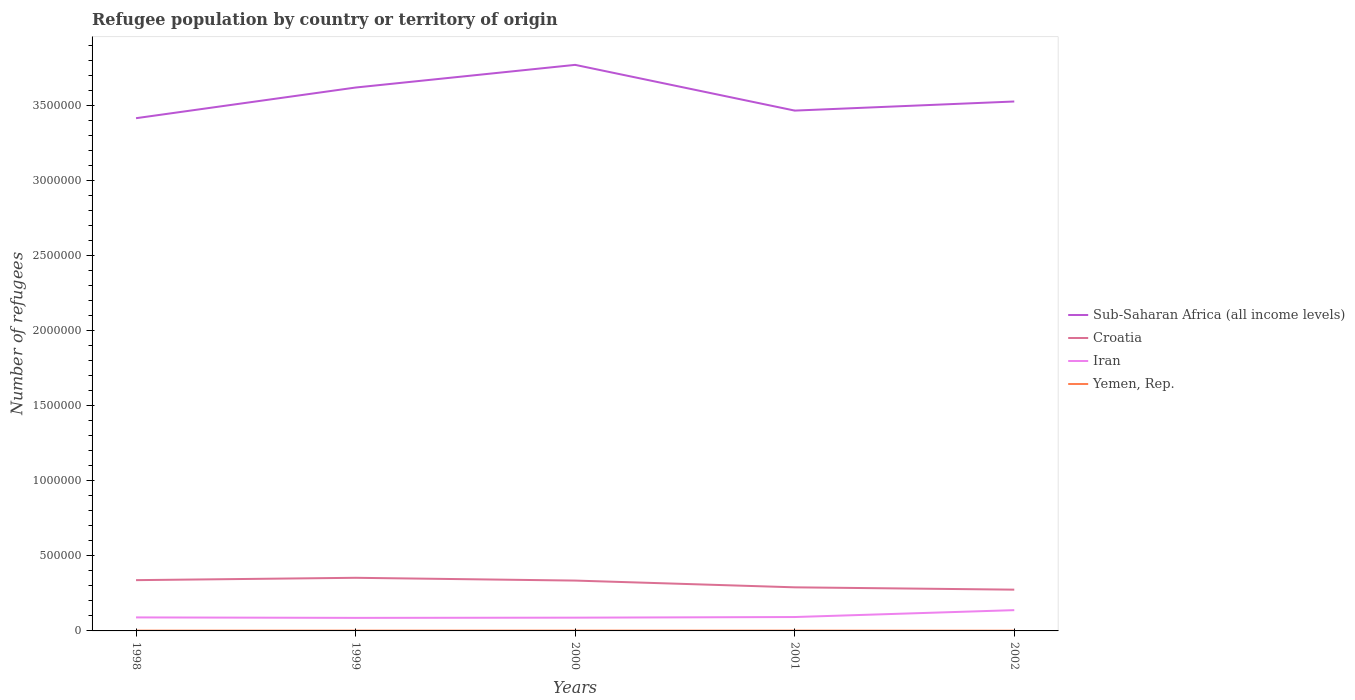Does the line corresponding to Sub-Saharan Africa (all income levels) intersect with the line corresponding to Yemen, Rep.?
Give a very brief answer. No. Is the number of lines equal to the number of legend labels?
Give a very brief answer. Yes. Across all years, what is the maximum number of refugees in Iran?
Provide a short and direct response. 8.69e+04. In which year was the number of refugees in Croatia maximum?
Keep it short and to the point. 2002. What is the total number of refugees in Iran in the graph?
Ensure brevity in your answer.  1701. What is the difference between the highest and the second highest number of refugees in Sub-Saharan Africa (all income levels)?
Ensure brevity in your answer.  3.55e+05. How many years are there in the graph?
Offer a terse response. 5. Does the graph contain any zero values?
Ensure brevity in your answer.  No. Does the graph contain grids?
Your answer should be compact. No. Where does the legend appear in the graph?
Your answer should be compact. Center right. How many legend labels are there?
Provide a short and direct response. 4. How are the legend labels stacked?
Keep it short and to the point. Vertical. What is the title of the graph?
Your answer should be very brief. Refugee population by country or territory of origin. Does "Thailand" appear as one of the legend labels in the graph?
Provide a succinct answer. No. What is the label or title of the Y-axis?
Your answer should be very brief. Number of refugees. What is the Number of refugees of Sub-Saharan Africa (all income levels) in 1998?
Offer a very short reply. 3.41e+06. What is the Number of refugees of Croatia in 1998?
Your answer should be compact. 3.38e+05. What is the Number of refugees of Iran in 1998?
Offer a terse response. 9.00e+04. What is the Number of refugees of Yemen, Rep. in 1998?
Make the answer very short. 1935. What is the Number of refugees in Sub-Saharan Africa (all income levels) in 1999?
Provide a succinct answer. 3.62e+06. What is the Number of refugees of Croatia in 1999?
Give a very brief answer. 3.54e+05. What is the Number of refugees of Iran in 1999?
Make the answer very short. 8.69e+04. What is the Number of refugees in Yemen, Rep. in 1999?
Your answer should be very brief. 2022. What is the Number of refugees in Sub-Saharan Africa (all income levels) in 2000?
Provide a short and direct response. 3.77e+06. What is the Number of refugees in Croatia in 2000?
Provide a short and direct response. 3.35e+05. What is the Number of refugees in Iran in 2000?
Your answer should be compact. 8.83e+04. What is the Number of refugees of Yemen, Rep. in 2000?
Offer a terse response. 2113. What is the Number of refugees in Sub-Saharan Africa (all income levels) in 2001?
Your answer should be compact. 3.46e+06. What is the Number of refugees in Croatia in 2001?
Offer a terse response. 2.90e+05. What is the Number of refugees of Iran in 2001?
Keep it short and to the point. 9.25e+04. What is the Number of refugees of Yemen, Rep. in 2001?
Provide a short and direct response. 1985. What is the Number of refugees in Sub-Saharan Africa (all income levels) in 2002?
Your response must be concise. 3.53e+06. What is the Number of refugees in Croatia in 2002?
Your answer should be compact. 2.75e+05. What is the Number of refugees of Iran in 2002?
Offer a terse response. 1.38e+05. What is the Number of refugees in Yemen, Rep. in 2002?
Give a very brief answer. 1600. Across all years, what is the maximum Number of refugees in Sub-Saharan Africa (all income levels)?
Your answer should be compact. 3.77e+06. Across all years, what is the maximum Number of refugees of Croatia?
Your answer should be very brief. 3.54e+05. Across all years, what is the maximum Number of refugees in Iran?
Give a very brief answer. 1.38e+05. Across all years, what is the maximum Number of refugees of Yemen, Rep.?
Offer a terse response. 2113. Across all years, what is the minimum Number of refugees of Sub-Saharan Africa (all income levels)?
Give a very brief answer. 3.41e+06. Across all years, what is the minimum Number of refugees of Croatia?
Your answer should be very brief. 2.75e+05. Across all years, what is the minimum Number of refugees of Iran?
Give a very brief answer. 8.69e+04. Across all years, what is the minimum Number of refugees of Yemen, Rep.?
Make the answer very short. 1600. What is the total Number of refugees of Sub-Saharan Africa (all income levels) in the graph?
Give a very brief answer. 1.78e+07. What is the total Number of refugees of Croatia in the graph?
Ensure brevity in your answer.  1.59e+06. What is the total Number of refugees of Iran in the graph?
Your response must be concise. 4.96e+05. What is the total Number of refugees in Yemen, Rep. in the graph?
Your answer should be very brief. 9655. What is the difference between the Number of refugees of Sub-Saharan Africa (all income levels) in 1998 and that in 1999?
Provide a succinct answer. -2.04e+05. What is the difference between the Number of refugees in Croatia in 1998 and that in 1999?
Keep it short and to the point. -1.56e+04. What is the difference between the Number of refugees of Iran in 1998 and that in 1999?
Your answer should be very brief. 3124. What is the difference between the Number of refugees of Yemen, Rep. in 1998 and that in 1999?
Give a very brief answer. -87. What is the difference between the Number of refugees of Sub-Saharan Africa (all income levels) in 1998 and that in 2000?
Offer a very short reply. -3.55e+05. What is the difference between the Number of refugees of Croatia in 1998 and that in 2000?
Ensure brevity in your answer.  2890. What is the difference between the Number of refugees of Iran in 1998 and that in 2000?
Provide a short and direct response. 1701. What is the difference between the Number of refugees in Yemen, Rep. in 1998 and that in 2000?
Keep it short and to the point. -178. What is the difference between the Number of refugees in Sub-Saharan Africa (all income levels) in 1998 and that in 2001?
Your response must be concise. -5.06e+04. What is the difference between the Number of refugees of Croatia in 1998 and that in 2001?
Make the answer very short. 4.78e+04. What is the difference between the Number of refugees of Iran in 1998 and that in 2001?
Your answer should be very brief. -2512. What is the difference between the Number of refugees in Yemen, Rep. in 1998 and that in 2001?
Your answer should be very brief. -50. What is the difference between the Number of refugees of Sub-Saharan Africa (all income levels) in 1998 and that in 2002?
Your response must be concise. -1.11e+05. What is the difference between the Number of refugees in Croatia in 1998 and that in 2002?
Your answer should be compact. 6.33e+04. What is the difference between the Number of refugees of Iran in 1998 and that in 2002?
Offer a terse response. -4.84e+04. What is the difference between the Number of refugees in Yemen, Rep. in 1998 and that in 2002?
Ensure brevity in your answer.  335. What is the difference between the Number of refugees of Sub-Saharan Africa (all income levels) in 1999 and that in 2000?
Your answer should be compact. -1.51e+05. What is the difference between the Number of refugees in Croatia in 1999 and that in 2000?
Offer a very short reply. 1.85e+04. What is the difference between the Number of refugees of Iran in 1999 and that in 2000?
Offer a terse response. -1423. What is the difference between the Number of refugees in Yemen, Rep. in 1999 and that in 2000?
Provide a short and direct response. -91. What is the difference between the Number of refugees in Sub-Saharan Africa (all income levels) in 1999 and that in 2001?
Offer a terse response. 1.54e+05. What is the difference between the Number of refugees in Croatia in 1999 and that in 2001?
Ensure brevity in your answer.  6.34e+04. What is the difference between the Number of refugees of Iran in 1999 and that in 2001?
Ensure brevity in your answer.  -5636. What is the difference between the Number of refugees of Yemen, Rep. in 1999 and that in 2001?
Ensure brevity in your answer.  37. What is the difference between the Number of refugees in Sub-Saharan Africa (all income levels) in 1999 and that in 2002?
Keep it short and to the point. 9.30e+04. What is the difference between the Number of refugees in Croatia in 1999 and that in 2002?
Your answer should be compact. 7.89e+04. What is the difference between the Number of refugees of Iran in 1999 and that in 2002?
Offer a terse response. -5.15e+04. What is the difference between the Number of refugees of Yemen, Rep. in 1999 and that in 2002?
Ensure brevity in your answer.  422. What is the difference between the Number of refugees of Sub-Saharan Africa (all income levels) in 2000 and that in 2001?
Offer a terse response. 3.04e+05. What is the difference between the Number of refugees of Croatia in 2000 and that in 2001?
Your response must be concise. 4.49e+04. What is the difference between the Number of refugees of Iran in 2000 and that in 2001?
Keep it short and to the point. -4213. What is the difference between the Number of refugees in Yemen, Rep. in 2000 and that in 2001?
Provide a short and direct response. 128. What is the difference between the Number of refugees of Sub-Saharan Africa (all income levels) in 2000 and that in 2002?
Keep it short and to the point. 2.44e+05. What is the difference between the Number of refugees of Croatia in 2000 and that in 2002?
Provide a short and direct response. 6.04e+04. What is the difference between the Number of refugees in Iran in 2000 and that in 2002?
Your answer should be very brief. -5.01e+04. What is the difference between the Number of refugees in Yemen, Rep. in 2000 and that in 2002?
Offer a terse response. 513. What is the difference between the Number of refugees in Sub-Saharan Africa (all income levels) in 2001 and that in 2002?
Provide a short and direct response. -6.06e+04. What is the difference between the Number of refugees in Croatia in 2001 and that in 2002?
Your response must be concise. 1.55e+04. What is the difference between the Number of refugees in Iran in 2001 and that in 2002?
Make the answer very short. -4.59e+04. What is the difference between the Number of refugees of Yemen, Rep. in 2001 and that in 2002?
Make the answer very short. 385. What is the difference between the Number of refugees in Sub-Saharan Africa (all income levels) in 1998 and the Number of refugees in Croatia in 1999?
Offer a terse response. 3.06e+06. What is the difference between the Number of refugees in Sub-Saharan Africa (all income levels) in 1998 and the Number of refugees in Iran in 1999?
Offer a very short reply. 3.33e+06. What is the difference between the Number of refugees of Sub-Saharan Africa (all income levels) in 1998 and the Number of refugees of Yemen, Rep. in 1999?
Make the answer very short. 3.41e+06. What is the difference between the Number of refugees in Croatia in 1998 and the Number of refugees in Iran in 1999?
Give a very brief answer. 2.51e+05. What is the difference between the Number of refugees in Croatia in 1998 and the Number of refugees in Yemen, Rep. in 1999?
Your response must be concise. 3.36e+05. What is the difference between the Number of refugees in Iran in 1998 and the Number of refugees in Yemen, Rep. in 1999?
Ensure brevity in your answer.  8.80e+04. What is the difference between the Number of refugees in Sub-Saharan Africa (all income levels) in 1998 and the Number of refugees in Croatia in 2000?
Provide a short and direct response. 3.08e+06. What is the difference between the Number of refugees in Sub-Saharan Africa (all income levels) in 1998 and the Number of refugees in Iran in 2000?
Make the answer very short. 3.33e+06. What is the difference between the Number of refugees in Sub-Saharan Africa (all income levels) in 1998 and the Number of refugees in Yemen, Rep. in 2000?
Make the answer very short. 3.41e+06. What is the difference between the Number of refugees of Croatia in 1998 and the Number of refugees of Iran in 2000?
Offer a terse response. 2.50e+05. What is the difference between the Number of refugees of Croatia in 1998 and the Number of refugees of Yemen, Rep. in 2000?
Offer a terse response. 3.36e+05. What is the difference between the Number of refugees in Iran in 1998 and the Number of refugees in Yemen, Rep. in 2000?
Make the answer very short. 8.79e+04. What is the difference between the Number of refugees in Sub-Saharan Africa (all income levels) in 1998 and the Number of refugees in Croatia in 2001?
Your answer should be very brief. 3.12e+06. What is the difference between the Number of refugees in Sub-Saharan Africa (all income levels) in 1998 and the Number of refugees in Iran in 2001?
Provide a short and direct response. 3.32e+06. What is the difference between the Number of refugees of Sub-Saharan Africa (all income levels) in 1998 and the Number of refugees of Yemen, Rep. in 2001?
Offer a very short reply. 3.41e+06. What is the difference between the Number of refugees in Croatia in 1998 and the Number of refugees in Iran in 2001?
Offer a terse response. 2.46e+05. What is the difference between the Number of refugees of Croatia in 1998 and the Number of refugees of Yemen, Rep. in 2001?
Your answer should be compact. 3.36e+05. What is the difference between the Number of refugees in Iran in 1998 and the Number of refugees in Yemen, Rep. in 2001?
Your answer should be very brief. 8.80e+04. What is the difference between the Number of refugees in Sub-Saharan Africa (all income levels) in 1998 and the Number of refugees in Croatia in 2002?
Offer a very short reply. 3.14e+06. What is the difference between the Number of refugees in Sub-Saharan Africa (all income levels) in 1998 and the Number of refugees in Iran in 2002?
Your answer should be very brief. 3.28e+06. What is the difference between the Number of refugees in Sub-Saharan Africa (all income levels) in 1998 and the Number of refugees in Yemen, Rep. in 2002?
Offer a terse response. 3.41e+06. What is the difference between the Number of refugees of Croatia in 1998 and the Number of refugees of Iran in 2002?
Provide a short and direct response. 2.00e+05. What is the difference between the Number of refugees of Croatia in 1998 and the Number of refugees of Yemen, Rep. in 2002?
Make the answer very short. 3.36e+05. What is the difference between the Number of refugees of Iran in 1998 and the Number of refugees of Yemen, Rep. in 2002?
Give a very brief answer. 8.84e+04. What is the difference between the Number of refugees of Sub-Saharan Africa (all income levels) in 1999 and the Number of refugees of Croatia in 2000?
Make the answer very short. 3.28e+06. What is the difference between the Number of refugees of Sub-Saharan Africa (all income levels) in 1999 and the Number of refugees of Iran in 2000?
Provide a succinct answer. 3.53e+06. What is the difference between the Number of refugees in Sub-Saharan Africa (all income levels) in 1999 and the Number of refugees in Yemen, Rep. in 2000?
Your answer should be very brief. 3.62e+06. What is the difference between the Number of refugees in Croatia in 1999 and the Number of refugees in Iran in 2000?
Provide a short and direct response. 2.65e+05. What is the difference between the Number of refugees of Croatia in 1999 and the Number of refugees of Yemen, Rep. in 2000?
Your answer should be very brief. 3.52e+05. What is the difference between the Number of refugees in Iran in 1999 and the Number of refugees in Yemen, Rep. in 2000?
Offer a very short reply. 8.47e+04. What is the difference between the Number of refugees in Sub-Saharan Africa (all income levels) in 1999 and the Number of refugees in Croatia in 2001?
Offer a very short reply. 3.33e+06. What is the difference between the Number of refugees in Sub-Saharan Africa (all income levels) in 1999 and the Number of refugees in Iran in 2001?
Your response must be concise. 3.53e+06. What is the difference between the Number of refugees in Sub-Saharan Africa (all income levels) in 1999 and the Number of refugees in Yemen, Rep. in 2001?
Make the answer very short. 3.62e+06. What is the difference between the Number of refugees of Croatia in 1999 and the Number of refugees of Iran in 2001?
Your answer should be very brief. 2.61e+05. What is the difference between the Number of refugees of Croatia in 1999 and the Number of refugees of Yemen, Rep. in 2001?
Your response must be concise. 3.52e+05. What is the difference between the Number of refugees in Iran in 1999 and the Number of refugees in Yemen, Rep. in 2001?
Ensure brevity in your answer.  8.49e+04. What is the difference between the Number of refugees of Sub-Saharan Africa (all income levels) in 1999 and the Number of refugees of Croatia in 2002?
Offer a terse response. 3.34e+06. What is the difference between the Number of refugees of Sub-Saharan Africa (all income levels) in 1999 and the Number of refugees of Iran in 2002?
Make the answer very short. 3.48e+06. What is the difference between the Number of refugees of Sub-Saharan Africa (all income levels) in 1999 and the Number of refugees of Yemen, Rep. in 2002?
Your response must be concise. 3.62e+06. What is the difference between the Number of refugees in Croatia in 1999 and the Number of refugees in Iran in 2002?
Provide a succinct answer. 2.15e+05. What is the difference between the Number of refugees of Croatia in 1999 and the Number of refugees of Yemen, Rep. in 2002?
Your response must be concise. 3.52e+05. What is the difference between the Number of refugees of Iran in 1999 and the Number of refugees of Yemen, Rep. in 2002?
Provide a succinct answer. 8.53e+04. What is the difference between the Number of refugees in Sub-Saharan Africa (all income levels) in 2000 and the Number of refugees in Croatia in 2001?
Your response must be concise. 3.48e+06. What is the difference between the Number of refugees in Sub-Saharan Africa (all income levels) in 2000 and the Number of refugees in Iran in 2001?
Offer a terse response. 3.68e+06. What is the difference between the Number of refugees of Sub-Saharan Africa (all income levels) in 2000 and the Number of refugees of Yemen, Rep. in 2001?
Offer a terse response. 3.77e+06. What is the difference between the Number of refugees in Croatia in 2000 and the Number of refugees in Iran in 2001?
Your answer should be very brief. 2.43e+05. What is the difference between the Number of refugees in Croatia in 2000 and the Number of refugees in Yemen, Rep. in 2001?
Provide a succinct answer. 3.33e+05. What is the difference between the Number of refugees in Iran in 2000 and the Number of refugees in Yemen, Rep. in 2001?
Your response must be concise. 8.63e+04. What is the difference between the Number of refugees in Sub-Saharan Africa (all income levels) in 2000 and the Number of refugees in Croatia in 2002?
Your answer should be very brief. 3.49e+06. What is the difference between the Number of refugees in Sub-Saharan Africa (all income levels) in 2000 and the Number of refugees in Iran in 2002?
Offer a terse response. 3.63e+06. What is the difference between the Number of refugees of Sub-Saharan Africa (all income levels) in 2000 and the Number of refugees of Yemen, Rep. in 2002?
Offer a very short reply. 3.77e+06. What is the difference between the Number of refugees in Croatia in 2000 and the Number of refugees in Iran in 2002?
Your answer should be compact. 1.97e+05. What is the difference between the Number of refugees of Croatia in 2000 and the Number of refugees of Yemen, Rep. in 2002?
Your response must be concise. 3.34e+05. What is the difference between the Number of refugees of Iran in 2000 and the Number of refugees of Yemen, Rep. in 2002?
Make the answer very short. 8.67e+04. What is the difference between the Number of refugees of Sub-Saharan Africa (all income levels) in 2001 and the Number of refugees of Croatia in 2002?
Offer a very short reply. 3.19e+06. What is the difference between the Number of refugees of Sub-Saharan Africa (all income levels) in 2001 and the Number of refugees of Iran in 2002?
Your answer should be compact. 3.33e+06. What is the difference between the Number of refugees of Sub-Saharan Africa (all income levels) in 2001 and the Number of refugees of Yemen, Rep. in 2002?
Provide a succinct answer. 3.46e+06. What is the difference between the Number of refugees in Croatia in 2001 and the Number of refugees in Iran in 2002?
Offer a terse response. 1.52e+05. What is the difference between the Number of refugees of Croatia in 2001 and the Number of refugees of Yemen, Rep. in 2002?
Your response must be concise. 2.89e+05. What is the difference between the Number of refugees of Iran in 2001 and the Number of refugees of Yemen, Rep. in 2002?
Offer a very short reply. 9.09e+04. What is the average Number of refugees in Sub-Saharan Africa (all income levels) per year?
Offer a very short reply. 3.56e+06. What is the average Number of refugees in Croatia per year?
Make the answer very short. 3.18e+05. What is the average Number of refugees of Iran per year?
Your answer should be compact. 9.92e+04. What is the average Number of refugees of Yemen, Rep. per year?
Keep it short and to the point. 1931. In the year 1998, what is the difference between the Number of refugees of Sub-Saharan Africa (all income levels) and Number of refugees of Croatia?
Your response must be concise. 3.08e+06. In the year 1998, what is the difference between the Number of refugees in Sub-Saharan Africa (all income levels) and Number of refugees in Iran?
Your response must be concise. 3.32e+06. In the year 1998, what is the difference between the Number of refugees of Sub-Saharan Africa (all income levels) and Number of refugees of Yemen, Rep.?
Provide a short and direct response. 3.41e+06. In the year 1998, what is the difference between the Number of refugees in Croatia and Number of refugees in Iran?
Ensure brevity in your answer.  2.48e+05. In the year 1998, what is the difference between the Number of refugees in Croatia and Number of refugees in Yemen, Rep.?
Provide a succinct answer. 3.36e+05. In the year 1998, what is the difference between the Number of refugees of Iran and Number of refugees of Yemen, Rep.?
Your response must be concise. 8.80e+04. In the year 1999, what is the difference between the Number of refugees of Sub-Saharan Africa (all income levels) and Number of refugees of Croatia?
Give a very brief answer. 3.26e+06. In the year 1999, what is the difference between the Number of refugees of Sub-Saharan Africa (all income levels) and Number of refugees of Iran?
Offer a terse response. 3.53e+06. In the year 1999, what is the difference between the Number of refugees of Sub-Saharan Africa (all income levels) and Number of refugees of Yemen, Rep.?
Your response must be concise. 3.62e+06. In the year 1999, what is the difference between the Number of refugees in Croatia and Number of refugees in Iran?
Make the answer very short. 2.67e+05. In the year 1999, what is the difference between the Number of refugees of Croatia and Number of refugees of Yemen, Rep.?
Your response must be concise. 3.52e+05. In the year 1999, what is the difference between the Number of refugees of Iran and Number of refugees of Yemen, Rep.?
Offer a very short reply. 8.48e+04. In the year 2000, what is the difference between the Number of refugees in Sub-Saharan Africa (all income levels) and Number of refugees in Croatia?
Offer a terse response. 3.43e+06. In the year 2000, what is the difference between the Number of refugees of Sub-Saharan Africa (all income levels) and Number of refugees of Iran?
Keep it short and to the point. 3.68e+06. In the year 2000, what is the difference between the Number of refugees of Sub-Saharan Africa (all income levels) and Number of refugees of Yemen, Rep.?
Your answer should be very brief. 3.77e+06. In the year 2000, what is the difference between the Number of refugees of Croatia and Number of refugees of Iran?
Make the answer very short. 2.47e+05. In the year 2000, what is the difference between the Number of refugees in Croatia and Number of refugees in Yemen, Rep.?
Make the answer very short. 3.33e+05. In the year 2000, what is the difference between the Number of refugees of Iran and Number of refugees of Yemen, Rep.?
Provide a short and direct response. 8.62e+04. In the year 2001, what is the difference between the Number of refugees in Sub-Saharan Africa (all income levels) and Number of refugees in Croatia?
Give a very brief answer. 3.17e+06. In the year 2001, what is the difference between the Number of refugees of Sub-Saharan Africa (all income levels) and Number of refugees of Iran?
Make the answer very short. 3.37e+06. In the year 2001, what is the difference between the Number of refugees of Sub-Saharan Africa (all income levels) and Number of refugees of Yemen, Rep.?
Offer a terse response. 3.46e+06. In the year 2001, what is the difference between the Number of refugees of Croatia and Number of refugees of Iran?
Your answer should be very brief. 1.98e+05. In the year 2001, what is the difference between the Number of refugees of Croatia and Number of refugees of Yemen, Rep.?
Offer a very short reply. 2.88e+05. In the year 2001, what is the difference between the Number of refugees in Iran and Number of refugees in Yemen, Rep.?
Your answer should be compact. 9.05e+04. In the year 2002, what is the difference between the Number of refugees in Sub-Saharan Africa (all income levels) and Number of refugees in Croatia?
Provide a short and direct response. 3.25e+06. In the year 2002, what is the difference between the Number of refugees in Sub-Saharan Africa (all income levels) and Number of refugees in Iran?
Provide a short and direct response. 3.39e+06. In the year 2002, what is the difference between the Number of refugees in Sub-Saharan Africa (all income levels) and Number of refugees in Yemen, Rep.?
Your answer should be compact. 3.52e+06. In the year 2002, what is the difference between the Number of refugees in Croatia and Number of refugees in Iran?
Your response must be concise. 1.36e+05. In the year 2002, what is the difference between the Number of refugees in Croatia and Number of refugees in Yemen, Rep.?
Ensure brevity in your answer.  2.73e+05. In the year 2002, what is the difference between the Number of refugees in Iran and Number of refugees in Yemen, Rep.?
Provide a short and direct response. 1.37e+05. What is the ratio of the Number of refugees of Sub-Saharan Africa (all income levels) in 1998 to that in 1999?
Offer a terse response. 0.94. What is the ratio of the Number of refugees of Croatia in 1998 to that in 1999?
Ensure brevity in your answer.  0.96. What is the ratio of the Number of refugees in Iran in 1998 to that in 1999?
Your answer should be very brief. 1.04. What is the ratio of the Number of refugees in Sub-Saharan Africa (all income levels) in 1998 to that in 2000?
Offer a terse response. 0.91. What is the ratio of the Number of refugees of Croatia in 1998 to that in 2000?
Provide a succinct answer. 1.01. What is the ratio of the Number of refugees in Iran in 1998 to that in 2000?
Your answer should be compact. 1.02. What is the ratio of the Number of refugees of Yemen, Rep. in 1998 to that in 2000?
Your answer should be very brief. 0.92. What is the ratio of the Number of refugees in Sub-Saharan Africa (all income levels) in 1998 to that in 2001?
Make the answer very short. 0.99. What is the ratio of the Number of refugees of Croatia in 1998 to that in 2001?
Offer a very short reply. 1.16. What is the ratio of the Number of refugees in Iran in 1998 to that in 2001?
Your answer should be very brief. 0.97. What is the ratio of the Number of refugees in Yemen, Rep. in 1998 to that in 2001?
Your answer should be very brief. 0.97. What is the ratio of the Number of refugees of Sub-Saharan Africa (all income levels) in 1998 to that in 2002?
Give a very brief answer. 0.97. What is the ratio of the Number of refugees in Croatia in 1998 to that in 2002?
Keep it short and to the point. 1.23. What is the ratio of the Number of refugees of Iran in 1998 to that in 2002?
Offer a very short reply. 0.65. What is the ratio of the Number of refugees in Yemen, Rep. in 1998 to that in 2002?
Provide a succinct answer. 1.21. What is the ratio of the Number of refugees in Croatia in 1999 to that in 2000?
Offer a terse response. 1.06. What is the ratio of the Number of refugees of Iran in 1999 to that in 2000?
Your response must be concise. 0.98. What is the ratio of the Number of refugees in Yemen, Rep. in 1999 to that in 2000?
Your response must be concise. 0.96. What is the ratio of the Number of refugees in Sub-Saharan Africa (all income levels) in 1999 to that in 2001?
Your response must be concise. 1.04. What is the ratio of the Number of refugees of Croatia in 1999 to that in 2001?
Ensure brevity in your answer.  1.22. What is the ratio of the Number of refugees of Iran in 1999 to that in 2001?
Give a very brief answer. 0.94. What is the ratio of the Number of refugees of Yemen, Rep. in 1999 to that in 2001?
Give a very brief answer. 1.02. What is the ratio of the Number of refugees of Sub-Saharan Africa (all income levels) in 1999 to that in 2002?
Your answer should be very brief. 1.03. What is the ratio of the Number of refugees in Croatia in 1999 to that in 2002?
Make the answer very short. 1.29. What is the ratio of the Number of refugees in Iran in 1999 to that in 2002?
Give a very brief answer. 0.63. What is the ratio of the Number of refugees of Yemen, Rep. in 1999 to that in 2002?
Your answer should be very brief. 1.26. What is the ratio of the Number of refugees of Sub-Saharan Africa (all income levels) in 2000 to that in 2001?
Provide a succinct answer. 1.09. What is the ratio of the Number of refugees of Croatia in 2000 to that in 2001?
Give a very brief answer. 1.15. What is the ratio of the Number of refugees in Iran in 2000 to that in 2001?
Make the answer very short. 0.95. What is the ratio of the Number of refugees of Yemen, Rep. in 2000 to that in 2001?
Offer a terse response. 1.06. What is the ratio of the Number of refugees in Sub-Saharan Africa (all income levels) in 2000 to that in 2002?
Offer a terse response. 1.07. What is the ratio of the Number of refugees of Croatia in 2000 to that in 2002?
Make the answer very short. 1.22. What is the ratio of the Number of refugees in Iran in 2000 to that in 2002?
Your answer should be very brief. 0.64. What is the ratio of the Number of refugees in Yemen, Rep. in 2000 to that in 2002?
Provide a short and direct response. 1.32. What is the ratio of the Number of refugees in Sub-Saharan Africa (all income levels) in 2001 to that in 2002?
Make the answer very short. 0.98. What is the ratio of the Number of refugees of Croatia in 2001 to that in 2002?
Ensure brevity in your answer.  1.06. What is the ratio of the Number of refugees of Iran in 2001 to that in 2002?
Provide a succinct answer. 0.67. What is the ratio of the Number of refugees of Yemen, Rep. in 2001 to that in 2002?
Provide a succinct answer. 1.24. What is the difference between the highest and the second highest Number of refugees of Sub-Saharan Africa (all income levels)?
Offer a terse response. 1.51e+05. What is the difference between the highest and the second highest Number of refugees in Croatia?
Ensure brevity in your answer.  1.56e+04. What is the difference between the highest and the second highest Number of refugees in Iran?
Ensure brevity in your answer.  4.59e+04. What is the difference between the highest and the second highest Number of refugees of Yemen, Rep.?
Provide a short and direct response. 91. What is the difference between the highest and the lowest Number of refugees in Sub-Saharan Africa (all income levels)?
Your answer should be compact. 3.55e+05. What is the difference between the highest and the lowest Number of refugees of Croatia?
Your response must be concise. 7.89e+04. What is the difference between the highest and the lowest Number of refugees of Iran?
Provide a succinct answer. 5.15e+04. What is the difference between the highest and the lowest Number of refugees of Yemen, Rep.?
Offer a terse response. 513. 